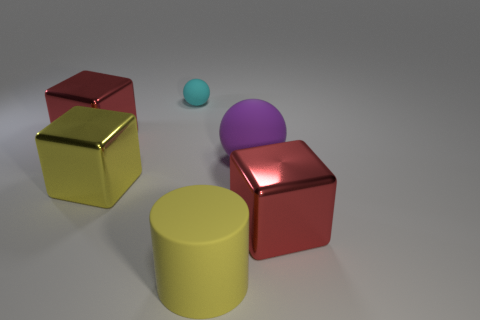What number of cylinders are the same material as the large ball?
Ensure brevity in your answer.  1. Do the red object on the right side of the cyan sphere and the tiny cyan sphere have the same material?
Provide a short and direct response. No. Are there an equal number of tiny balls in front of the big yellow metal block and yellow shiny objects?
Keep it short and to the point. No. How big is the yellow rubber thing?
Give a very brief answer. Large. What material is the thing that is the same color as the matte cylinder?
Ensure brevity in your answer.  Metal. How many large things are the same color as the small sphere?
Your response must be concise. 0. Do the yellow rubber object and the cyan matte ball have the same size?
Ensure brevity in your answer.  No. There is a red block that is behind the red cube that is right of the tiny matte ball; what size is it?
Offer a terse response. Large. There is a cylinder; is its color the same as the big metallic block behind the large yellow metal object?
Provide a short and direct response. No. Are there any other rubber blocks of the same size as the yellow block?
Keep it short and to the point. No. 